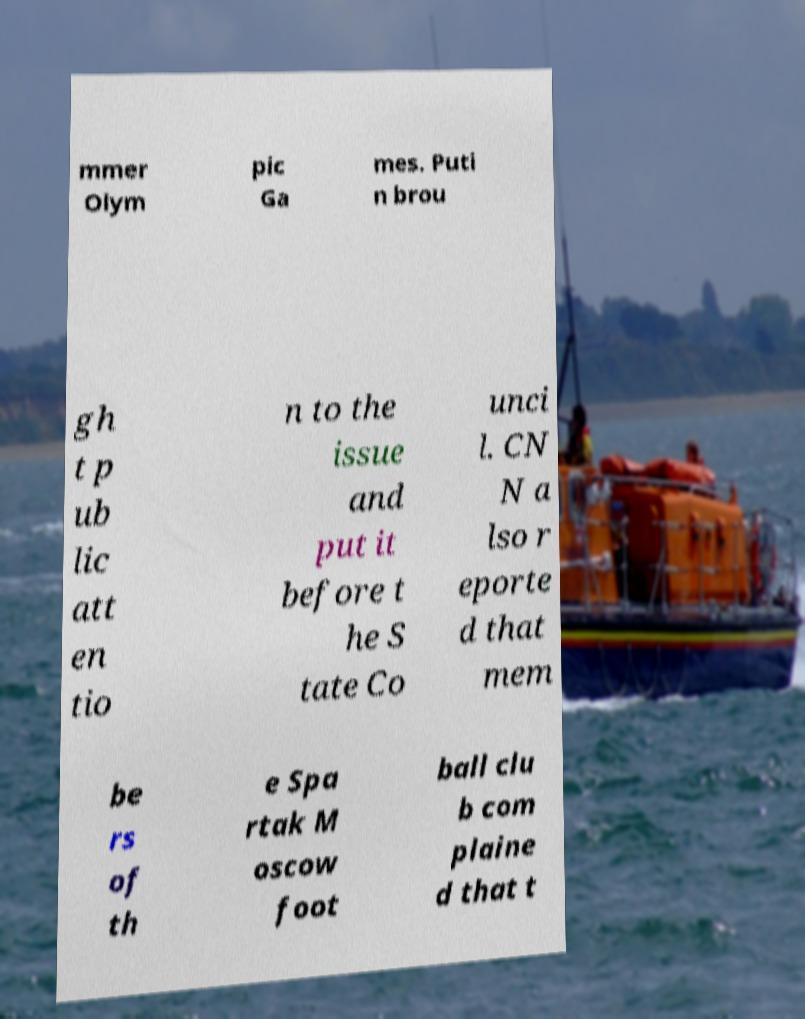I need the written content from this picture converted into text. Can you do that? mmer Olym pic Ga mes. Puti n brou gh t p ub lic att en tio n to the issue and put it before t he S tate Co unci l. CN N a lso r eporte d that mem be rs of th e Spa rtak M oscow foot ball clu b com plaine d that t 